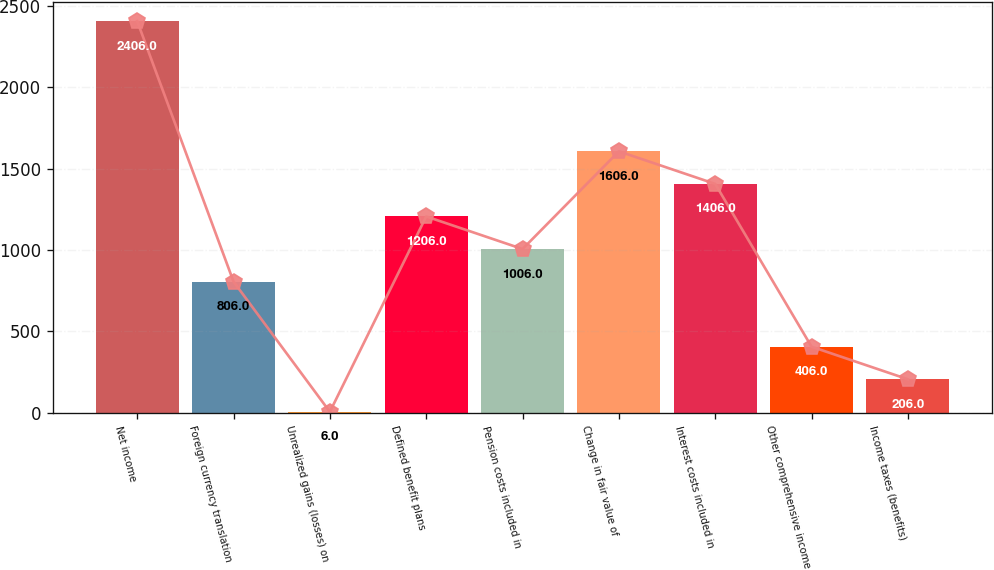<chart> <loc_0><loc_0><loc_500><loc_500><bar_chart><fcel>Net income<fcel>Foreign currency translation<fcel>Unrealized gains (losses) on<fcel>Defined benefit plans<fcel>Pension costs included in<fcel>Change in fair value of<fcel>Interest costs included in<fcel>Other comprehensive income<fcel>Income taxes (benefits)<nl><fcel>2406<fcel>806<fcel>6<fcel>1206<fcel>1006<fcel>1606<fcel>1406<fcel>406<fcel>206<nl></chart> 